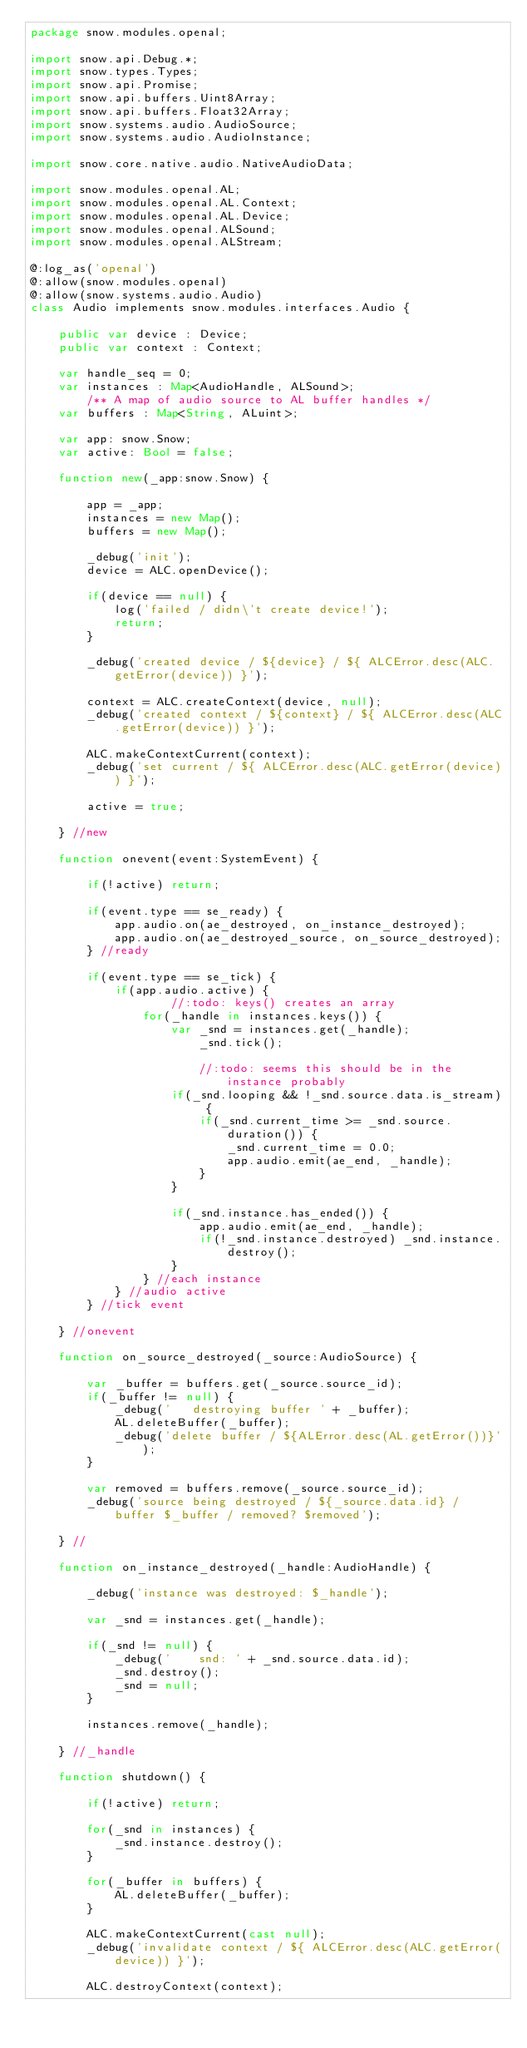Convert code to text. <code><loc_0><loc_0><loc_500><loc_500><_Haxe_>package snow.modules.openal;

import snow.api.Debug.*;
import snow.types.Types;
import snow.api.Promise;
import snow.api.buffers.Uint8Array;
import snow.api.buffers.Float32Array;
import snow.systems.audio.AudioSource;
import snow.systems.audio.AudioInstance;

import snow.core.native.audio.NativeAudioData;

import snow.modules.openal.AL;
import snow.modules.openal.AL.Context;
import snow.modules.openal.AL.Device;
import snow.modules.openal.ALSound;
import snow.modules.openal.ALStream;

@:log_as('openal')
@:allow(snow.modules.openal)
@:allow(snow.systems.audio.Audio)
class Audio implements snow.modules.interfaces.Audio {

    public var device : Device;
    public var context : Context;

    var handle_seq = 0;
    var instances : Map<AudioHandle, ALSound>;
        /** A map of audio source to AL buffer handles */
    var buffers : Map<String, ALuint>;

    var app: snow.Snow;
    var active: Bool = false;

    function new(_app:snow.Snow) {

        app = _app;
        instances = new Map();
        buffers = new Map();

        _debug('init');
        device = ALC.openDevice();

        if(device == null) {
            log('failed / didn\'t create device!');
            return;
        }

        _debug('created device / ${device} / ${ ALCError.desc(ALC.getError(device)) }');

        context = ALC.createContext(device, null);
        _debug('created context / ${context} / ${ ALCError.desc(ALC.getError(device)) }');

        ALC.makeContextCurrent(context);
        _debug('set current / ${ ALCError.desc(ALC.getError(device)) }');

        active = true;

    } //new

    function onevent(event:SystemEvent) {

        if(!active) return;

        if(event.type == se_ready) {
            app.audio.on(ae_destroyed, on_instance_destroyed);
            app.audio.on(ae_destroyed_source, on_source_destroyed);
        } //ready

        if(event.type == se_tick) {
            if(app.audio.active) {
                    //:todo: keys() creates an array
                for(_handle in instances.keys()) {
                    var _snd = instances.get(_handle);
                        _snd.tick();

                        //:todo: seems this should be in the instance probably
                    if(_snd.looping && !_snd.source.data.is_stream) {
                        if(_snd.current_time >= _snd.source.duration()) {
                            _snd.current_time = 0.0;
                            app.audio.emit(ae_end, _handle);
                        }
                    }

                    if(_snd.instance.has_ended()) {
                        app.audio.emit(ae_end, _handle);
                        if(!_snd.instance.destroyed) _snd.instance.destroy();
                    }
                } //each instance
            } //audio active
        } //tick event

    } //onevent

    function on_source_destroyed(_source:AudioSource) {

        var _buffer = buffers.get(_source.source_id);
        if(_buffer != null) {
            _debug('   destroying buffer ' + _buffer);
            AL.deleteBuffer(_buffer);
            _debug('delete buffer / ${ALError.desc(AL.getError())}');
        }

        var removed = buffers.remove(_source.source_id);
        _debug('source being destroyed / ${_source.data.id} / buffer $_buffer / removed? $removed');

    } //

    function on_instance_destroyed(_handle:AudioHandle) {

        _debug('instance was destroyed: $_handle');

        var _snd = instances.get(_handle);

        if(_snd != null) {
            _debug('    snd: ' + _snd.source.data.id);
            _snd.destroy();
            _snd = null;
        }

        instances.remove(_handle);

    } //_handle

    function shutdown() {

        if(!active) return;

        for(_snd in instances) {
            _snd.instance.destroy();
        }

        for(_buffer in buffers) {
            AL.deleteBuffer(_buffer);
        }

        ALC.makeContextCurrent(cast null);
        _debug('invalidate context / ${ ALCError.desc(ALC.getError(device)) }');

        ALC.destroyContext(context);</code> 